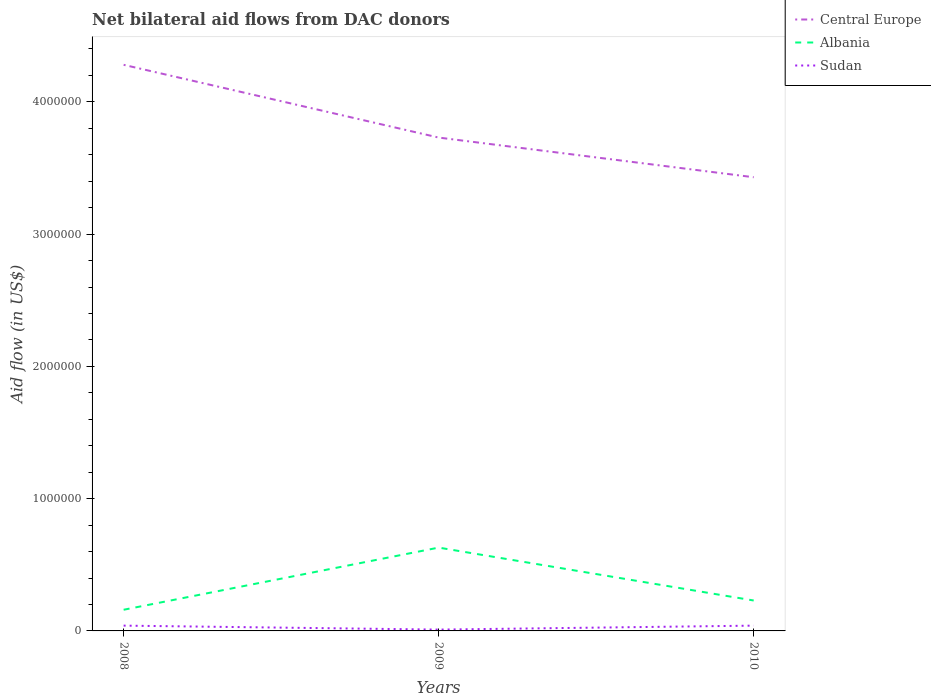Does the line corresponding to Albania intersect with the line corresponding to Central Europe?
Your answer should be very brief. No. Across all years, what is the maximum net bilateral aid flow in Central Europe?
Provide a succinct answer. 3.43e+06. In which year was the net bilateral aid flow in Sudan maximum?
Keep it short and to the point. 2009. What is the difference between the highest and the second highest net bilateral aid flow in Sudan?
Offer a terse response. 3.00e+04. How many years are there in the graph?
Offer a very short reply. 3. What is the difference between two consecutive major ticks on the Y-axis?
Your response must be concise. 1.00e+06. Are the values on the major ticks of Y-axis written in scientific E-notation?
Your response must be concise. No. Does the graph contain grids?
Make the answer very short. No. Where does the legend appear in the graph?
Keep it short and to the point. Top right. How many legend labels are there?
Keep it short and to the point. 3. How are the legend labels stacked?
Offer a terse response. Vertical. What is the title of the graph?
Offer a very short reply. Net bilateral aid flows from DAC donors. What is the label or title of the Y-axis?
Ensure brevity in your answer.  Aid flow (in US$). What is the Aid flow (in US$) of Central Europe in 2008?
Offer a very short reply. 4.28e+06. What is the Aid flow (in US$) of Albania in 2008?
Provide a succinct answer. 1.60e+05. What is the Aid flow (in US$) of Central Europe in 2009?
Provide a succinct answer. 3.73e+06. What is the Aid flow (in US$) of Albania in 2009?
Make the answer very short. 6.30e+05. What is the Aid flow (in US$) of Central Europe in 2010?
Give a very brief answer. 3.43e+06. What is the Aid flow (in US$) in Sudan in 2010?
Give a very brief answer. 4.00e+04. Across all years, what is the maximum Aid flow (in US$) in Central Europe?
Your response must be concise. 4.28e+06. Across all years, what is the maximum Aid flow (in US$) of Albania?
Ensure brevity in your answer.  6.30e+05. Across all years, what is the maximum Aid flow (in US$) in Sudan?
Your answer should be compact. 4.00e+04. Across all years, what is the minimum Aid flow (in US$) of Central Europe?
Keep it short and to the point. 3.43e+06. What is the total Aid flow (in US$) in Central Europe in the graph?
Offer a terse response. 1.14e+07. What is the total Aid flow (in US$) in Albania in the graph?
Provide a short and direct response. 1.02e+06. What is the total Aid flow (in US$) of Sudan in the graph?
Offer a very short reply. 9.00e+04. What is the difference between the Aid flow (in US$) in Central Europe in 2008 and that in 2009?
Your answer should be compact. 5.50e+05. What is the difference between the Aid flow (in US$) in Albania in 2008 and that in 2009?
Give a very brief answer. -4.70e+05. What is the difference between the Aid flow (in US$) of Sudan in 2008 and that in 2009?
Give a very brief answer. 3.00e+04. What is the difference between the Aid flow (in US$) in Central Europe in 2008 and that in 2010?
Keep it short and to the point. 8.50e+05. What is the difference between the Aid flow (in US$) in Albania in 2008 and that in 2010?
Provide a succinct answer. -7.00e+04. What is the difference between the Aid flow (in US$) of Sudan in 2008 and that in 2010?
Offer a terse response. 0. What is the difference between the Aid flow (in US$) of Central Europe in 2009 and that in 2010?
Ensure brevity in your answer.  3.00e+05. What is the difference between the Aid flow (in US$) in Sudan in 2009 and that in 2010?
Keep it short and to the point. -3.00e+04. What is the difference between the Aid flow (in US$) in Central Europe in 2008 and the Aid flow (in US$) in Albania in 2009?
Give a very brief answer. 3.65e+06. What is the difference between the Aid flow (in US$) of Central Europe in 2008 and the Aid flow (in US$) of Sudan in 2009?
Ensure brevity in your answer.  4.27e+06. What is the difference between the Aid flow (in US$) in Albania in 2008 and the Aid flow (in US$) in Sudan in 2009?
Offer a very short reply. 1.50e+05. What is the difference between the Aid flow (in US$) in Central Europe in 2008 and the Aid flow (in US$) in Albania in 2010?
Keep it short and to the point. 4.05e+06. What is the difference between the Aid flow (in US$) in Central Europe in 2008 and the Aid flow (in US$) in Sudan in 2010?
Your answer should be very brief. 4.24e+06. What is the difference between the Aid flow (in US$) in Albania in 2008 and the Aid flow (in US$) in Sudan in 2010?
Provide a succinct answer. 1.20e+05. What is the difference between the Aid flow (in US$) of Central Europe in 2009 and the Aid flow (in US$) of Albania in 2010?
Provide a short and direct response. 3.50e+06. What is the difference between the Aid flow (in US$) of Central Europe in 2009 and the Aid flow (in US$) of Sudan in 2010?
Give a very brief answer. 3.69e+06. What is the difference between the Aid flow (in US$) in Albania in 2009 and the Aid flow (in US$) in Sudan in 2010?
Your response must be concise. 5.90e+05. What is the average Aid flow (in US$) in Central Europe per year?
Offer a terse response. 3.81e+06. What is the average Aid flow (in US$) in Albania per year?
Offer a very short reply. 3.40e+05. In the year 2008, what is the difference between the Aid flow (in US$) of Central Europe and Aid flow (in US$) of Albania?
Your answer should be very brief. 4.12e+06. In the year 2008, what is the difference between the Aid flow (in US$) in Central Europe and Aid flow (in US$) in Sudan?
Ensure brevity in your answer.  4.24e+06. In the year 2009, what is the difference between the Aid flow (in US$) in Central Europe and Aid flow (in US$) in Albania?
Keep it short and to the point. 3.10e+06. In the year 2009, what is the difference between the Aid flow (in US$) of Central Europe and Aid flow (in US$) of Sudan?
Provide a succinct answer. 3.72e+06. In the year 2009, what is the difference between the Aid flow (in US$) of Albania and Aid flow (in US$) of Sudan?
Your response must be concise. 6.20e+05. In the year 2010, what is the difference between the Aid flow (in US$) in Central Europe and Aid flow (in US$) in Albania?
Offer a very short reply. 3.20e+06. In the year 2010, what is the difference between the Aid flow (in US$) of Central Europe and Aid flow (in US$) of Sudan?
Make the answer very short. 3.39e+06. In the year 2010, what is the difference between the Aid flow (in US$) of Albania and Aid flow (in US$) of Sudan?
Give a very brief answer. 1.90e+05. What is the ratio of the Aid flow (in US$) in Central Europe in 2008 to that in 2009?
Your response must be concise. 1.15. What is the ratio of the Aid flow (in US$) of Albania in 2008 to that in 2009?
Provide a succinct answer. 0.25. What is the ratio of the Aid flow (in US$) of Central Europe in 2008 to that in 2010?
Your answer should be compact. 1.25. What is the ratio of the Aid flow (in US$) in Albania in 2008 to that in 2010?
Your response must be concise. 0.7. What is the ratio of the Aid flow (in US$) of Sudan in 2008 to that in 2010?
Offer a very short reply. 1. What is the ratio of the Aid flow (in US$) in Central Europe in 2009 to that in 2010?
Provide a succinct answer. 1.09. What is the ratio of the Aid flow (in US$) in Albania in 2009 to that in 2010?
Your response must be concise. 2.74. What is the difference between the highest and the second highest Aid flow (in US$) in Central Europe?
Ensure brevity in your answer.  5.50e+05. What is the difference between the highest and the second highest Aid flow (in US$) in Albania?
Make the answer very short. 4.00e+05. What is the difference between the highest and the second highest Aid flow (in US$) of Sudan?
Give a very brief answer. 0. What is the difference between the highest and the lowest Aid flow (in US$) of Central Europe?
Your response must be concise. 8.50e+05. What is the difference between the highest and the lowest Aid flow (in US$) in Albania?
Offer a terse response. 4.70e+05. What is the difference between the highest and the lowest Aid flow (in US$) in Sudan?
Provide a succinct answer. 3.00e+04. 